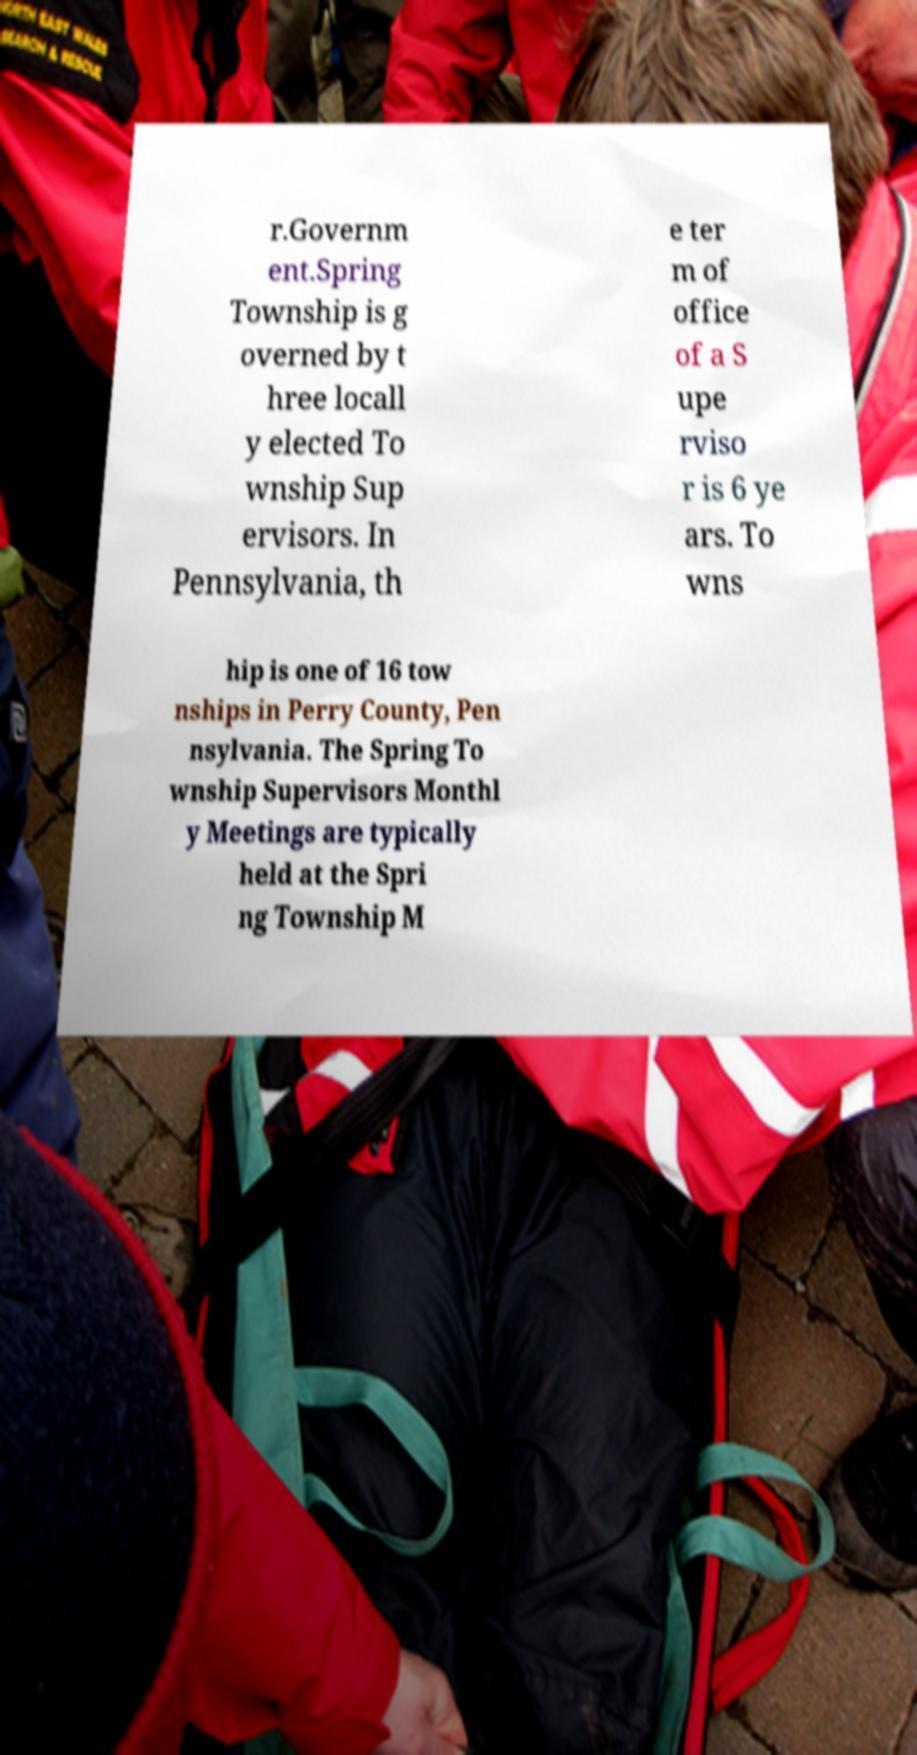There's text embedded in this image that I need extracted. Can you transcribe it verbatim? r.Governm ent.Spring Township is g overned by t hree locall y elected To wnship Sup ervisors. In Pennsylvania, th e ter m of office of a S upe rviso r is 6 ye ars. To wns hip is one of 16 tow nships in Perry County, Pen nsylvania. The Spring To wnship Supervisors Monthl y Meetings are typically held at the Spri ng Township M 